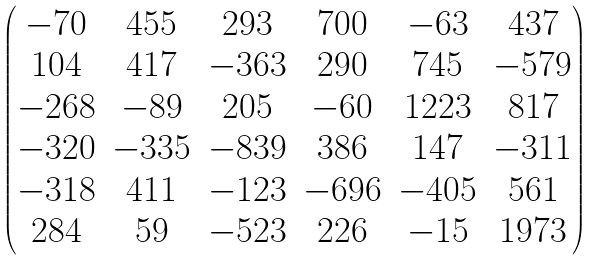Convert formula to latex. <formula><loc_0><loc_0><loc_500><loc_500>\begin{pmatrix} - 7 0 & 4 5 5 & 2 9 3 & 7 0 0 & - 6 3 & 4 3 7 \\ 1 0 4 & 4 1 7 & - 3 6 3 & 2 9 0 & 7 4 5 & - 5 7 9 \\ - 2 6 8 & - 8 9 & 2 0 5 & - 6 0 & 1 2 2 3 & 8 1 7 \\ - 3 2 0 & - 3 3 5 & - 8 3 9 & 3 8 6 & 1 4 7 & - 3 1 1 \\ - 3 1 8 & 4 1 1 & - 1 2 3 & - 6 9 6 & - 4 0 5 & 5 6 1 \\ 2 8 4 & 5 9 & - 5 2 3 & 2 2 6 & - 1 5 & 1 9 7 3 \end{pmatrix}</formula> 